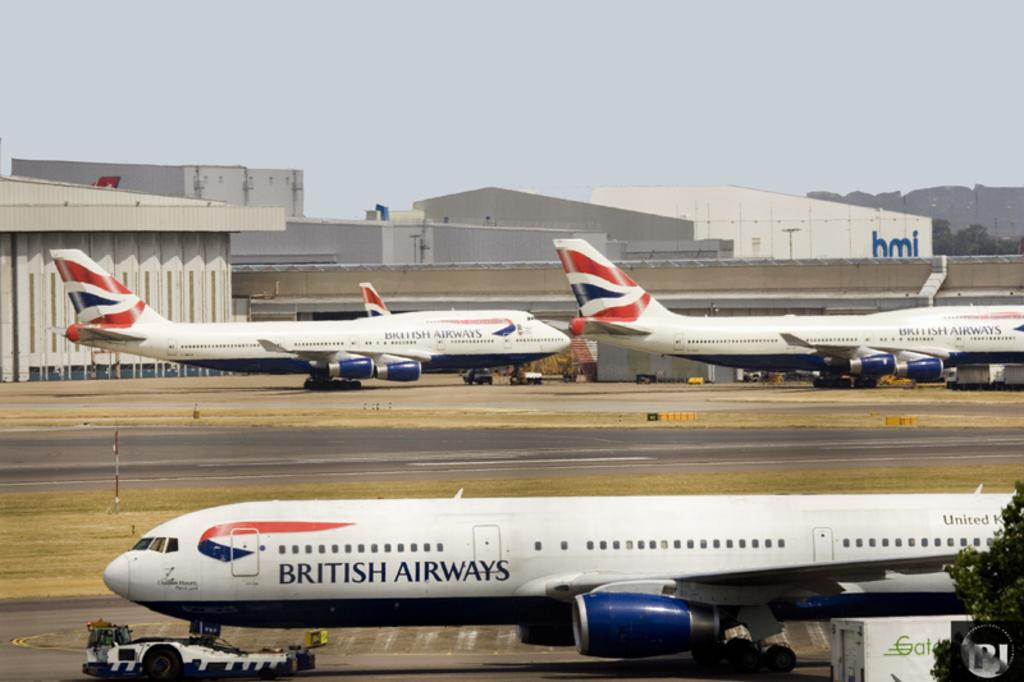What is the main subject of the image? The main subject of the image is aeroplanes. What other objects or elements can be seen in the image? There are trees and buildings visible in the image. What is visible in the background of the image? The sky is visible in the background of the image. Can you see any visible veins in the image? There are no visible veins in the image, as it features aeroplanes, trees, and buildings. Is there a stretch of water, such as a river, visible in the image? There is no stretch of water, such as a river, visible in the image. 